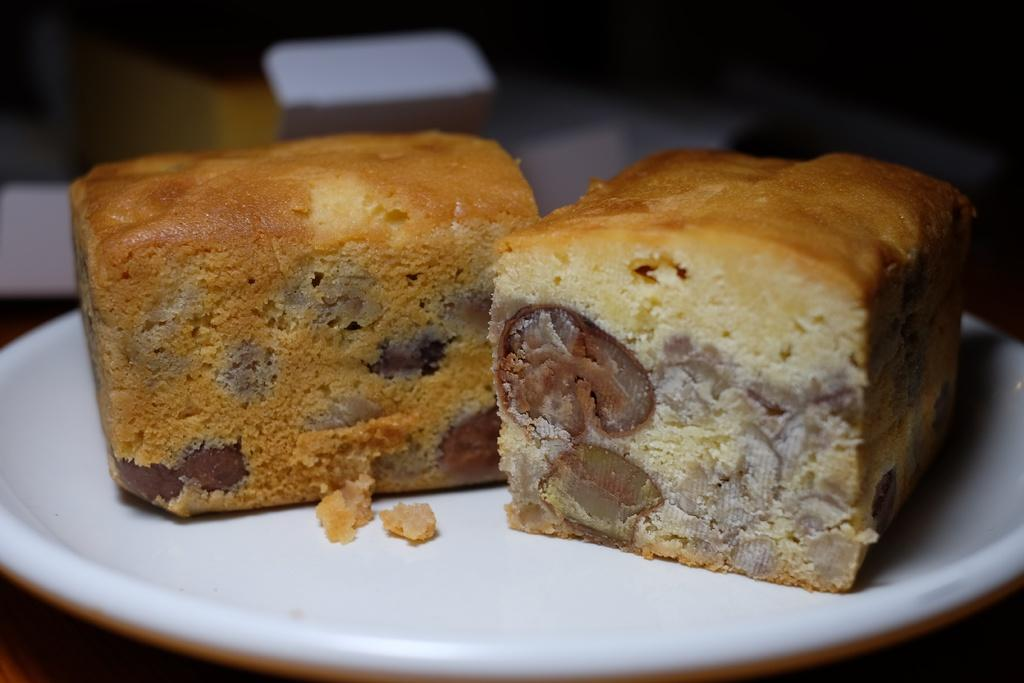What type of dessert can be seen in the image? There are two pieces of plum cake in the image. How is the plum cake presented in the image? The plum cake is on a plate. Can you describe the background of the image? The background of the image is blurred. Can you hear any noise coming from the window in the image? There is no window present in the image, so it is not possible to hear any noise coming from it. 